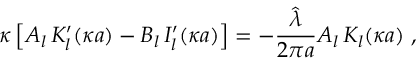Convert formula to latex. <formula><loc_0><loc_0><loc_500><loc_500>\kappa \left [ A _ { l } \, K _ { l } ^ { \prime } ( \kappa a ) - B _ { l } \, I _ { l } ^ { \prime } ( \kappa a ) \right ] = - \frac { \hat { \lambda } } { 2 \pi a } A _ { l } \, K _ { l } ( \kappa a ) \, ,</formula> 